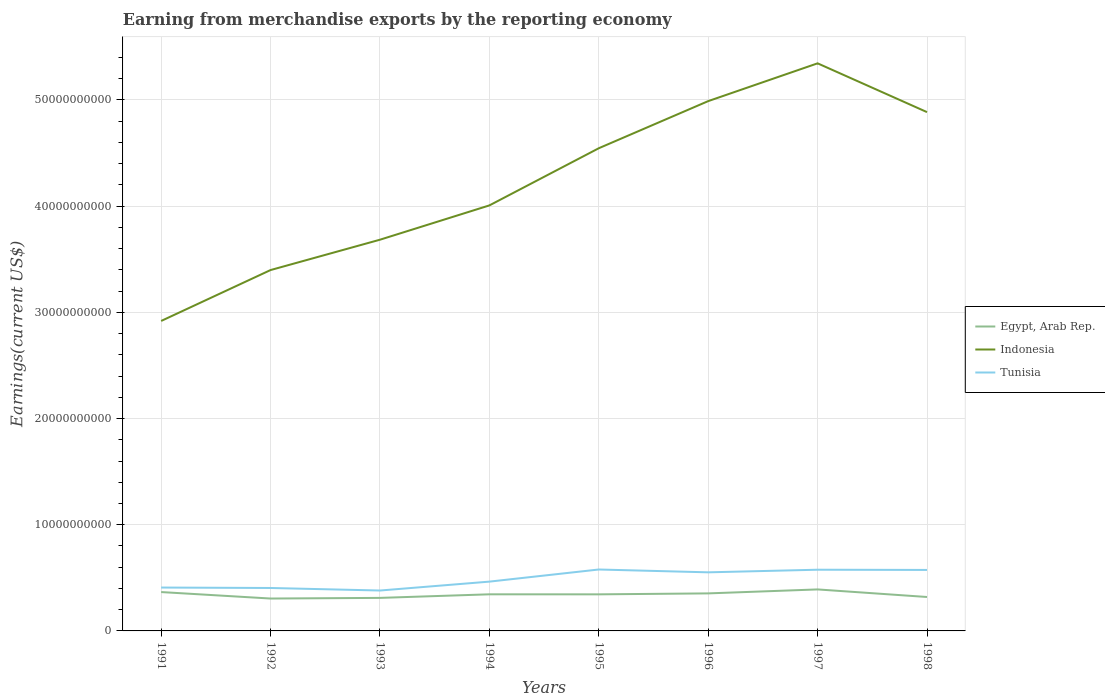How many different coloured lines are there?
Offer a very short reply. 3. Across all years, what is the maximum amount earned from merchandise exports in Egypt, Arab Rep.?
Give a very brief answer. 3.05e+09. In which year was the amount earned from merchandise exports in Egypt, Arab Rep. maximum?
Your answer should be very brief. 1992. What is the total amount earned from merchandise exports in Tunisia in the graph?
Ensure brevity in your answer.  -1.74e+09. What is the difference between the highest and the second highest amount earned from merchandise exports in Egypt, Arab Rep.?
Offer a terse response. 8.58e+08. What is the difference between the highest and the lowest amount earned from merchandise exports in Egypt, Arab Rep.?
Give a very brief answer. 5. Are the values on the major ticks of Y-axis written in scientific E-notation?
Offer a terse response. No. Does the graph contain grids?
Provide a short and direct response. Yes. How are the legend labels stacked?
Offer a terse response. Vertical. What is the title of the graph?
Your answer should be very brief. Earning from merchandise exports by the reporting economy. What is the label or title of the Y-axis?
Offer a terse response. Earnings(current US$). What is the Earnings(current US$) of Egypt, Arab Rep. in 1991?
Make the answer very short. 3.66e+09. What is the Earnings(current US$) of Indonesia in 1991?
Offer a very short reply. 2.92e+1. What is the Earnings(current US$) in Tunisia in 1991?
Offer a very short reply. 4.09e+09. What is the Earnings(current US$) of Egypt, Arab Rep. in 1992?
Provide a short and direct response. 3.05e+09. What is the Earnings(current US$) of Indonesia in 1992?
Provide a succinct answer. 3.40e+1. What is the Earnings(current US$) in Tunisia in 1992?
Ensure brevity in your answer.  4.04e+09. What is the Earnings(current US$) in Egypt, Arab Rep. in 1993?
Make the answer very short. 3.11e+09. What is the Earnings(current US$) of Indonesia in 1993?
Offer a very short reply. 3.68e+1. What is the Earnings(current US$) in Tunisia in 1993?
Offer a very short reply. 3.80e+09. What is the Earnings(current US$) in Egypt, Arab Rep. in 1994?
Your response must be concise. 3.45e+09. What is the Earnings(current US$) in Indonesia in 1994?
Make the answer very short. 4.01e+1. What is the Earnings(current US$) of Tunisia in 1994?
Give a very brief answer. 4.64e+09. What is the Earnings(current US$) of Egypt, Arab Rep. in 1995?
Your answer should be compact. 3.44e+09. What is the Earnings(current US$) in Indonesia in 1995?
Offer a terse response. 4.55e+1. What is the Earnings(current US$) in Tunisia in 1995?
Offer a very short reply. 5.78e+09. What is the Earnings(current US$) of Egypt, Arab Rep. in 1996?
Make the answer very short. 3.53e+09. What is the Earnings(current US$) in Indonesia in 1996?
Provide a succinct answer. 4.99e+1. What is the Earnings(current US$) of Tunisia in 1996?
Provide a succinct answer. 5.52e+09. What is the Earnings(current US$) of Egypt, Arab Rep. in 1997?
Make the answer very short. 3.91e+09. What is the Earnings(current US$) of Indonesia in 1997?
Your answer should be compact. 5.34e+1. What is the Earnings(current US$) of Tunisia in 1997?
Provide a succinct answer. 5.76e+09. What is the Earnings(current US$) in Egypt, Arab Rep. in 1998?
Keep it short and to the point. 3.20e+09. What is the Earnings(current US$) of Indonesia in 1998?
Offer a very short reply. 4.89e+1. What is the Earnings(current US$) of Tunisia in 1998?
Keep it short and to the point. 5.74e+09. Across all years, what is the maximum Earnings(current US$) in Egypt, Arab Rep.?
Your answer should be compact. 3.91e+09. Across all years, what is the maximum Earnings(current US$) of Indonesia?
Your answer should be very brief. 5.34e+1. Across all years, what is the maximum Earnings(current US$) in Tunisia?
Make the answer very short. 5.78e+09. Across all years, what is the minimum Earnings(current US$) in Egypt, Arab Rep.?
Give a very brief answer. 3.05e+09. Across all years, what is the minimum Earnings(current US$) of Indonesia?
Keep it short and to the point. 2.92e+1. Across all years, what is the minimum Earnings(current US$) in Tunisia?
Your answer should be compact. 3.80e+09. What is the total Earnings(current US$) of Egypt, Arab Rep. in the graph?
Provide a succinct answer. 2.73e+1. What is the total Earnings(current US$) in Indonesia in the graph?
Give a very brief answer. 3.38e+11. What is the total Earnings(current US$) in Tunisia in the graph?
Make the answer very short. 3.94e+1. What is the difference between the Earnings(current US$) of Egypt, Arab Rep. in 1991 and that in 1992?
Give a very brief answer. 6.09e+08. What is the difference between the Earnings(current US$) in Indonesia in 1991 and that in 1992?
Give a very brief answer. -4.79e+09. What is the difference between the Earnings(current US$) of Tunisia in 1991 and that in 1992?
Offer a very short reply. 4.13e+07. What is the difference between the Earnings(current US$) of Egypt, Arab Rep. in 1991 and that in 1993?
Your answer should be very brief. 5.49e+08. What is the difference between the Earnings(current US$) in Indonesia in 1991 and that in 1993?
Your response must be concise. -7.65e+09. What is the difference between the Earnings(current US$) in Tunisia in 1991 and that in 1993?
Provide a short and direct response. 2.81e+08. What is the difference between the Earnings(current US$) of Egypt, Arab Rep. in 1991 and that in 1994?
Your answer should be very brief. 2.12e+08. What is the difference between the Earnings(current US$) in Indonesia in 1991 and that in 1994?
Provide a succinct answer. -1.09e+1. What is the difference between the Earnings(current US$) of Tunisia in 1991 and that in 1994?
Your answer should be very brief. -5.57e+08. What is the difference between the Earnings(current US$) in Egypt, Arab Rep. in 1991 and that in 1995?
Provide a short and direct response. 2.15e+08. What is the difference between the Earnings(current US$) in Indonesia in 1991 and that in 1995?
Your response must be concise. -1.63e+1. What is the difference between the Earnings(current US$) of Tunisia in 1991 and that in 1995?
Give a very brief answer. -1.70e+09. What is the difference between the Earnings(current US$) of Egypt, Arab Rep. in 1991 and that in 1996?
Make the answer very short. 1.25e+08. What is the difference between the Earnings(current US$) in Indonesia in 1991 and that in 1996?
Provide a short and direct response. -2.07e+1. What is the difference between the Earnings(current US$) of Tunisia in 1991 and that in 1996?
Ensure brevity in your answer.  -1.43e+09. What is the difference between the Earnings(current US$) in Egypt, Arab Rep. in 1991 and that in 1997?
Offer a terse response. -2.49e+08. What is the difference between the Earnings(current US$) in Indonesia in 1991 and that in 1997?
Your answer should be compact. -2.43e+1. What is the difference between the Earnings(current US$) in Tunisia in 1991 and that in 1997?
Offer a terse response. -1.68e+09. What is the difference between the Earnings(current US$) in Egypt, Arab Rep. in 1991 and that in 1998?
Ensure brevity in your answer.  4.64e+08. What is the difference between the Earnings(current US$) of Indonesia in 1991 and that in 1998?
Provide a succinct answer. -1.97e+1. What is the difference between the Earnings(current US$) in Tunisia in 1991 and that in 1998?
Your answer should be very brief. -1.66e+09. What is the difference between the Earnings(current US$) of Egypt, Arab Rep. in 1992 and that in 1993?
Your answer should be very brief. -6.00e+07. What is the difference between the Earnings(current US$) in Indonesia in 1992 and that in 1993?
Your answer should be very brief. -2.86e+09. What is the difference between the Earnings(current US$) of Tunisia in 1992 and that in 1993?
Ensure brevity in your answer.  2.40e+08. What is the difference between the Earnings(current US$) of Egypt, Arab Rep. in 1992 and that in 1994?
Your answer should be compact. -3.98e+08. What is the difference between the Earnings(current US$) of Indonesia in 1992 and that in 1994?
Your answer should be very brief. -6.09e+09. What is the difference between the Earnings(current US$) of Tunisia in 1992 and that in 1994?
Give a very brief answer. -5.98e+08. What is the difference between the Earnings(current US$) in Egypt, Arab Rep. in 1992 and that in 1995?
Your answer should be compact. -3.94e+08. What is the difference between the Earnings(current US$) in Indonesia in 1992 and that in 1995?
Provide a succinct answer. -1.15e+1. What is the difference between the Earnings(current US$) of Tunisia in 1992 and that in 1995?
Offer a terse response. -1.74e+09. What is the difference between the Earnings(current US$) of Egypt, Arab Rep. in 1992 and that in 1996?
Ensure brevity in your answer.  -4.85e+08. What is the difference between the Earnings(current US$) of Indonesia in 1992 and that in 1996?
Ensure brevity in your answer.  -1.59e+1. What is the difference between the Earnings(current US$) in Tunisia in 1992 and that in 1996?
Provide a succinct answer. -1.47e+09. What is the difference between the Earnings(current US$) in Egypt, Arab Rep. in 1992 and that in 1997?
Offer a very short reply. -8.58e+08. What is the difference between the Earnings(current US$) of Indonesia in 1992 and that in 1997?
Offer a very short reply. -1.95e+1. What is the difference between the Earnings(current US$) in Tunisia in 1992 and that in 1997?
Your response must be concise. -1.72e+09. What is the difference between the Earnings(current US$) of Egypt, Arab Rep. in 1992 and that in 1998?
Provide a short and direct response. -1.45e+08. What is the difference between the Earnings(current US$) of Indonesia in 1992 and that in 1998?
Keep it short and to the point. -1.49e+1. What is the difference between the Earnings(current US$) of Tunisia in 1992 and that in 1998?
Offer a terse response. -1.70e+09. What is the difference between the Earnings(current US$) of Egypt, Arab Rep. in 1993 and that in 1994?
Provide a succinct answer. -3.38e+08. What is the difference between the Earnings(current US$) of Indonesia in 1993 and that in 1994?
Keep it short and to the point. -3.23e+09. What is the difference between the Earnings(current US$) of Tunisia in 1993 and that in 1994?
Provide a succinct answer. -8.38e+08. What is the difference between the Earnings(current US$) in Egypt, Arab Rep. in 1993 and that in 1995?
Offer a very short reply. -3.34e+08. What is the difference between the Earnings(current US$) of Indonesia in 1993 and that in 1995?
Provide a short and direct response. -8.61e+09. What is the difference between the Earnings(current US$) of Tunisia in 1993 and that in 1995?
Provide a short and direct response. -1.98e+09. What is the difference between the Earnings(current US$) of Egypt, Arab Rep. in 1993 and that in 1996?
Your answer should be very brief. -4.25e+08. What is the difference between the Earnings(current US$) of Indonesia in 1993 and that in 1996?
Make the answer very short. -1.31e+1. What is the difference between the Earnings(current US$) of Tunisia in 1993 and that in 1996?
Offer a very short reply. -1.71e+09. What is the difference between the Earnings(current US$) in Egypt, Arab Rep. in 1993 and that in 1997?
Make the answer very short. -7.98e+08. What is the difference between the Earnings(current US$) of Indonesia in 1993 and that in 1997?
Provide a succinct answer. -1.66e+1. What is the difference between the Earnings(current US$) in Tunisia in 1993 and that in 1997?
Provide a short and direct response. -1.96e+09. What is the difference between the Earnings(current US$) of Egypt, Arab Rep. in 1993 and that in 1998?
Keep it short and to the point. -8.53e+07. What is the difference between the Earnings(current US$) in Indonesia in 1993 and that in 1998?
Make the answer very short. -1.20e+1. What is the difference between the Earnings(current US$) of Tunisia in 1993 and that in 1998?
Give a very brief answer. -1.94e+09. What is the difference between the Earnings(current US$) of Egypt, Arab Rep. in 1994 and that in 1995?
Your answer should be compact. 3.36e+06. What is the difference between the Earnings(current US$) of Indonesia in 1994 and that in 1995?
Offer a very short reply. -5.38e+09. What is the difference between the Earnings(current US$) in Tunisia in 1994 and that in 1995?
Offer a terse response. -1.14e+09. What is the difference between the Earnings(current US$) of Egypt, Arab Rep. in 1994 and that in 1996?
Offer a terse response. -8.70e+07. What is the difference between the Earnings(current US$) in Indonesia in 1994 and that in 1996?
Keep it short and to the point. -9.82e+09. What is the difference between the Earnings(current US$) in Tunisia in 1994 and that in 1996?
Ensure brevity in your answer.  -8.76e+08. What is the difference between the Earnings(current US$) in Egypt, Arab Rep. in 1994 and that in 1997?
Your response must be concise. -4.60e+08. What is the difference between the Earnings(current US$) in Indonesia in 1994 and that in 1997?
Your answer should be compact. -1.34e+1. What is the difference between the Earnings(current US$) of Tunisia in 1994 and that in 1997?
Give a very brief answer. -1.12e+09. What is the difference between the Earnings(current US$) in Egypt, Arab Rep. in 1994 and that in 1998?
Offer a terse response. 2.52e+08. What is the difference between the Earnings(current US$) of Indonesia in 1994 and that in 1998?
Offer a very short reply. -8.79e+09. What is the difference between the Earnings(current US$) in Tunisia in 1994 and that in 1998?
Give a very brief answer. -1.10e+09. What is the difference between the Earnings(current US$) of Egypt, Arab Rep. in 1995 and that in 1996?
Make the answer very short. -9.03e+07. What is the difference between the Earnings(current US$) in Indonesia in 1995 and that in 1996?
Your answer should be very brief. -4.44e+09. What is the difference between the Earnings(current US$) of Tunisia in 1995 and that in 1996?
Keep it short and to the point. 2.66e+08. What is the difference between the Earnings(current US$) in Egypt, Arab Rep. in 1995 and that in 1997?
Provide a succinct answer. -4.64e+08. What is the difference between the Earnings(current US$) of Indonesia in 1995 and that in 1997?
Your answer should be very brief. -8.00e+09. What is the difference between the Earnings(current US$) in Tunisia in 1995 and that in 1997?
Make the answer very short. 2.11e+07. What is the difference between the Earnings(current US$) in Egypt, Arab Rep. in 1995 and that in 1998?
Keep it short and to the point. 2.49e+08. What is the difference between the Earnings(current US$) of Indonesia in 1995 and that in 1998?
Offer a terse response. -3.40e+09. What is the difference between the Earnings(current US$) in Tunisia in 1995 and that in 1998?
Make the answer very short. 4.17e+07. What is the difference between the Earnings(current US$) in Egypt, Arab Rep. in 1996 and that in 1997?
Keep it short and to the point. -3.73e+08. What is the difference between the Earnings(current US$) of Indonesia in 1996 and that in 1997?
Offer a very short reply. -3.56e+09. What is the difference between the Earnings(current US$) of Tunisia in 1996 and that in 1997?
Offer a terse response. -2.45e+08. What is the difference between the Earnings(current US$) in Egypt, Arab Rep. in 1996 and that in 1998?
Make the answer very short. 3.39e+08. What is the difference between the Earnings(current US$) in Indonesia in 1996 and that in 1998?
Your answer should be compact. 1.03e+09. What is the difference between the Earnings(current US$) of Tunisia in 1996 and that in 1998?
Your answer should be very brief. -2.24e+08. What is the difference between the Earnings(current US$) of Egypt, Arab Rep. in 1997 and that in 1998?
Keep it short and to the point. 7.13e+08. What is the difference between the Earnings(current US$) of Indonesia in 1997 and that in 1998?
Provide a short and direct response. 4.59e+09. What is the difference between the Earnings(current US$) of Tunisia in 1997 and that in 1998?
Make the answer very short. 2.06e+07. What is the difference between the Earnings(current US$) of Egypt, Arab Rep. in 1991 and the Earnings(current US$) of Indonesia in 1992?
Keep it short and to the point. -3.03e+1. What is the difference between the Earnings(current US$) of Egypt, Arab Rep. in 1991 and the Earnings(current US$) of Tunisia in 1992?
Provide a short and direct response. -3.85e+08. What is the difference between the Earnings(current US$) of Indonesia in 1991 and the Earnings(current US$) of Tunisia in 1992?
Your answer should be compact. 2.51e+1. What is the difference between the Earnings(current US$) in Egypt, Arab Rep. in 1991 and the Earnings(current US$) in Indonesia in 1993?
Your response must be concise. -3.32e+1. What is the difference between the Earnings(current US$) in Egypt, Arab Rep. in 1991 and the Earnings(current US$) in Tunisia in 1993?
Provide a short and direct response. -1.45e+08. What is the difference between the Earnings(current US$) in Indonesia in 1991 and the Earnings(current US$) in Tunisia in 1993?
Make the answer very short. 2.54e+1. What is the difference between the Earnings(current US$) in Egypt, Arab Rep. in 1991 and the Earnings(current US$) in Indonesia in 1994?
Provide a succinct answer. -3.64e+1. What is the difference between the Earnings(current US$) of Egypt, Arab Rep. in 1991 and the Earnings(current US$) of Tunisia in 1994?
Provide a succinct answer. -9.83e+08. What is the difference between the Earnings(current US$) in Indonesia in 1991 and the Earnings(current US$) in Tunisia in 1994?
Keep it short and to the point. 2.45e+1. What is the difference between the Earnings(current US$) in Egypt, Arab Rep. in 1991 and the Earnings(current US$) in Indonesia in 1995?
Your answer should be very brief. -4.18e+1. What is the difference between the Earnings(current US$) of Egypt, Arab Rep. in 1991 and the Earnings(current US$) of Tunisia in 1995?
Provide a short and direct response. -2.12e+09. What is the difference between the Earnings(current US$) of Indonesia in 1991 and the Earnings(current US$) of Tunisia in 1995?
Offer a very short reply. 2.34e+1. What is the difference between the Earnings(current US$) in Egypt, Arab Rep. in 1991 and the Earnings(current US$) in Indonesia in 1996?
Keep it short and to the point. -4.62e+1. What is the difference between the Earnings(current US$) in Egypt, Arab Rep. in 1991 and the Earnings(current US$) in Tunisia in 1996?
Give a very brief answer. -1.86e+09. What is the difference between the Earnings(current US$) of Indonesia in 1991 and the Earnings(current US$) of Tunisia in 1996?
Make the answer very short. 2.37e+1. What is the difference between the Earnings(current US$) of Egypt, Arab Rep. in 1991 and the Earnings(current US$) of Indonesia in 1997?
Keep it short and to the point. -4.98e+1. What is the difference between the Earnings(current US$) in Egypt, Arab Rep. in 1991 and the Earnings(current US$) in Tunisia in 1997?
Make the answer very short. -2.10e+09. What is the difference between the Earnings(current US$) of Indonesia in 1991 and the Earnings(current US$) of Tunisia in 1997?
Make the answer very short. 2.34e+1. What is the difference between the Earnings(current US$) in Egypt, Arab Rep. in 1991 and the Earnings(current US$) in Indonesia in 1998?
Ensure brevity in your answer.  -4.52e+1. What is the difference between the Earnings(current US$) in Egypt, Arab Rep. in 1991 and the Earnings(current US$) in Tunisia in 1998?
Your response must be concise. -2.08e+09. What is the difference between the Earnings(current US$) of Indonesia in 1991 and the Earnings(current US$) of Tunisia in 1998?
Offer a terse response. 2.34e+1. What is the difference between the Earnings(current US$) of Egypt, Arab Rep. in 1992 and the Earnings(current US$) of Indonesia in 1993?
Give a very brief answer. -3.38e+1. What is the difference between the Earnings(current US$) in Egypt, Arab Rep. in 1992 and the Earnings(current US$) in Tunisia in 1993?
Provide a succinct answer. -7.54e+08. What is the difference between the Earnings(current US$) of Indonesia in 1992 and the Earnings(current US$) of Tunisia in 1993?
Give a very brief answer. 3.02e+1. What is the difference between the Earnings(current US$) of Egypt, Arab Rep. in 1992 and the Earnings(current US$) of Indonesia in 1994?
Your answer should be very brief. -3.70e+1. What is the difference between the Earnings(current US$) in Egypt, Arab Rep. in 1992 and the Earnings(current US$) in Tunisia in 1994?
Ensure brevity in your answer.  -1.59e+09. What is the difference between the Earnings(current US$) of Indonesia in 1992 and the Earnings(current US$) of Tunisia in 1994?
Your answer should be very brief. 2.93e+1. What is the difference between the Earnings(current US$) in Egypt, Arab Rep. in 1992 and the Earnings(current US$) in Indonesia in 1995?
Your answer should be compact. -4.24e+1. What is the difference between the Earnings(current US$) in Egypt, Arab Rep. in 1992 and the Earnings(current US$) in Tunisia in 1995?
Give a very brief answer. -2.73e+09. What is the difference between the Earnings(current US$) of Indonesia in 1992 and the Earnings(current US$) of Tunisia in 1995?
Your response must be concise. 2.82e+1. What is the difference between the Earnings(current US$) in Egypt, Arab Rep. in 1992 and the Earnings(current US$) in Indonesia in 1996?
Keep it short and to the point. -4.68e+1. What is the difference between the Earnings(current US$) in Egypt, Arab Rep. in 1992 and the Earnings(current US$) in Tunisia in 1996?
Offer a very short reply. -2.47e+09. What is the difference between the Earnings(current US$) of Indonesia in 1992 and the Earnings(current US$) of Tunisia in 1996?
Make the answer very short. 2.85e+1. What is the difference between the Earnings(current US$) of Egypt, Arab Rep. in 1992 and the Earnings(current US$) of Indonesia in 1997?
Make the answer very short. -5.04e+1. What is the difference between the Earnings(current US$) in Egypt, Arab Rep. in 1992 and the Earnings(current US$) in Tunisia in 1997?
Your response must be concise. -2.71e+09. What is the difference between the Earnings(current US$) in Indonesia in 1992 and the Earnings(current US$) in Tunisia in 1997?
Offer a very short reply. 2.82e+1. What is the difference between the Earnings(current US$) of Egypt, Arab Rep. in 1992 and the Earnings(current US$) of Indonesia in 1998?
Give a very brief answer. -4.58e+1. What is the difference between the Earnings(current US$) of Egypt, Arab Rep. in 1992 and the Earnings(current US$) of Tunisia in 1998?
Your answer should be compact. -2.69e+09. What is the difference between the Earnings(current US$) in Indonesia in 1992 and the Earnings(current US$) in Tunisia in 1998?
Your answer should be very brief. 2.82e+1. What is the difference between the Earnings(current US$) in Egypt, Arab Rep. in 1993 and the Earnings(current US$) in Indonesia in 1994?
Provide a short and direct response. -3.70e+1. What is the difference between the Earnings(current US$) in Egypt, Arab Rep. in 1993 and the Earnings(current US$) in Tunisia in 1994?
Offer a very short reply. -1.53e+09. What is the difference between the Earnings(current US$) of Indonesia in 1993 and the Earnings(current US$) of Tunisia in 1994?
Your response must be concise. 3.22e+1. What is the difference between the Earnings(current US$) in Egypt, Arab Rep. in 1993 and the Earnings(current US$) in Indonesia in 1995?
Keep it short and to the point. -4.23e+1. What is the difference between the Earnings(current US$) of Egypt, Arab Rep. in 1993 and the Earnings(current US$) of Tunisia in 1995?
Your response must be concise. -2.67e+09. What is the difference between the Earnings(current US$) in Indonesia in 1993 and the Earnings(current US$) in Tunisia in 1995?
Keep it short and to the point. 3.11e+1. What is the difference between the Earnings(current US$) in Egypt, Arab Rep. in 1993 and the Earnings(current US$) in Indonesia in 1996?
Your response must be concise. -4.68e+1. What is the difference between the Earnings(current US$) in Egypt, Arab Rep. in 1993 and the Earnings(current US$) in Tunisia in 1996?
Make the answer very short. -2.41e+09. What is the difference between the Earnings(current US$) of Indonesia in 1993 and the Earnings(current US$) of Tunisia in 1996?
Provide a short and direct response. 3.13e+1. What is the difference between the Earnings(current US$) in Egypt, Arab Rep. in 1993 and the Earnings(current US$) in Indonesia in 1997?
Make the answer very short. -5.03e+1. What is the difference between the Earnings(current US$) in Egypt, Arab Rep. in 1993 and the Earnings(current US$) in Tunisia in 1997?
Your answer should be compact. -2.65e+09. What is the difference between the Earnings(current US$) of Indonesia in 1993 and the Earnings(current US$) of Tunisia in 1997?
Provide a succinct answer. 3.11e+1. What is the difference between the Earnings(current US$) of Egypt, Arab Rep. in 1993 and the Earnings(current US$) of Indonesia in 1998?
Keep it short and to the point. -4.57e+1. What is the difference between the Earnings(current US$) of Egypt, Arab Rep. in 1993 and the Earnings(current US$) of Tunisia in 1998?
Your response must be concise. -2.63e+09. What is the difference between the Earnings(current US$) in Indonesia in 1993 and the Earnings(current US$) in Tunisia in 1998?
Give a very brief answer. 3.11e+1. What is the difference between the Earnings(current US$) of Egypt, Arab Rep. in 1994 and the Earnings(current US$) of Indonesia in 1995?
Ensure brevity in your answer.  -4.20e+1. What is the difference between the Earnings(current US$) of Egypt, Arab Rep. in 1994 and the Earnings(current US$) of Tunisia in 1995?
Make the answer very short. -2.34e+09. What is the difference between the Earnings(current US$) of Indonesia in 1994 and the Earnings(current US$) of Tunisia in 1995?
Your response must be concise. 3.43e+1. What is the difference between the Earnings(current US$) in Egypt, Arab Rep. in 1994 and the Earnings(current US$) in Indonesia in 1996?
Ensure brevity in your answer.  -4.64e+1. What is the difference between the Earnings(current US$) in Egypt, Arab Rep. in 1994 and the Earnings(current US$) in Tunisia in 1996?
Give a very brief answer. -2.07e+09. What is the difference between the Earnings(current US$) of Indonesia in 1994 and the Earnings(current US$) of Tunisia in 1996?
Offer a terse response. 3.46e+1. What is the difference between the Earnings(current US$) in Egypt, Arab Rep. in 1994 and the Earnings(current US$) in Indonesia in 1997?
Offer a terse response. -5.00e+1. What is the difference between the Earnings(current US$) of Egypt, Arab Rep. in 1994 and the Earnings(current US$) of Tunisia in 1997?
Keep it short and to the point. -2.32e+09. What is the difference between the Earnings(current US$) of Indonesia in 1994 and the Earnings(current US$) of Tunisia in 1997?
Offer a very short reply. 3.43e+1. What is the difference between the Earnings(current US$) in Egypt, Arab Rep. in 1994 and the Earnings(current US$) in Indonesia in 1998?
Your answer should be compact. -4.54e+1. What is the difference between the Earnings(current US$) in Egypt, Arab Rep. in 1994 and the Earnings(current US$) in Tunisia in 1998?
Offer a very short reply. -2.29e+09. What is the difference between the Earnings(current US$) in Indonesia in 1994 and the Earnings(current US$) in Tunisia in 1998?
Your answer should be very brief. 3.43e+1. What is the difference between the Earnings(current US$) of Egypt, Arab Rep. in 1995 and the Earnings(current US$) of Indonesia in 1996?
Provide a short and direct response. -4.64e+1. What is the difference between the Earnings(current US$) in Egypt, Arab Rep. in 1995 and the Earnings(current US$) in Tunisia in 1996?
Your response must be concise. -2.07e+09. What is the difference between the Earnings(current US$) of Indonesia in 1995 and the Earnings(current US$) of Tunisia in 1996?
Ensure brevity in your answer.  3.99e+1. What is the difference between the Earnings(current US$) in Egypt, Arab Rep. in 1995 and the Earnings(current US$) in Indonesia in 1997?
Your answer should be very brief. -5.00e+1. What is the difference between the Earnings(current US$) in Egypt, Arab Rep. in 1995 and the Earnings(current US$) in Tunisia in 1997?
Provide a succinct answer. -2.32e+09. What is the difference between the Earnings(current US$) of Indonesia in 1995 and the Earnings(current US$) of Tunisia in 1997?
Your answer should be very brief. 3.97e+1. What is the difference between the Earnings(current US$) of Egypt, Arab Rep. in 1995 and the Earnings(current US$) of Indonesia in 1998?
Make the answer very short. -4.54e+1. What is the difference between the Earnings(current US$) in Egypt, Arab Rep. in 1995 and the Earnings(current US$) in Tunisia in 1998?
Your answer should be very brief. -2.30e+09. What is the difference between the Earnings(current US$) in Indonesia in 1995 and the Earnings(current US$) in Tunisia in 1998?
Provide a short and direct response. 3.97e+1. What is the difference between the Earnings(current US$) of Egypt, Arab Rep. in 1996 and the Earnings(current US$) of Indonesia in 1997?
Your response must be concise. -4.99e+1. What is the difference between the Earnings(current US$) of Egypt, Arab Rep. in 1996 and the Earnings(current US$) of Tunisia in 1997?
Offer a very short reply. -2.23e+09. What is the difference between the Earnings(current US$) in Indonesia in 1996 and the Earnings(current US$) in Tunisia in 1997?
Offer a terse response. 4.41e+1. What is the difference between the Earnings(current US$) in Egypt, Arab Rep. in 1996 and the Earnings(current US$) in Indonesia in 1998?
Keep it short and to the point. -4.53e+1. What is the difference between the Earnings(current US$) in Egypt, Arab Rep. in 1996 and the Earnings(current US$) in Tunisia in 1998?
Give a very brief answer. -2.21e+09. What is the difference between the Earnings(current US$) in Indonesia in 1996 and the Earnings(current US$) in Tunisia in 1998?
Provide a short and direct response. 4.41e+1. What is the difference between the Earnings(current US$) in Egypt, Arab Rep. in 1997 and the Earnings(current US$) in Indonesia in 1998?
Offer a very short reply. -4.49e+1. What is the difference between the Earnings(current US$) in Egypt, Arab Rep. in 1997 and the Earnings(current US$) in Tunisia in 1998?
Your answer should be compact. -1.83e+09. What is the difference between the Earnings(current US$) in Indonesia in 1997 and the Earnings(current US$) in Tunisia in 1998?
Your response must be concise. 4.77e+1. What is the average Earnings(current US$) in Egypt, Arab Rep. per year?
Offer a terse response. 3.42e+09. What is the average Earnings(current US$) in Indonesia per year?
Your response must be concise. 4.22e+1. What is the average Earnings(current US$) of Tunisia per year?
Ensure brevity in your answer.  4.92e+09. In the year 1991, what is the difference between the Earnings(current US$) of Egypt, Arab Rep. and Earnings(current US$) of Indonesia?
Keep it short and to the point. -2.55e+1. In the year 1991, what is the difference between the Earnings(current US$) in Egypt, Arab Rep. and Earnings(current US$) in Tunisia?
Your answer should be very brief. -4.26e+08. In the year 1991, what is the difference between the Earnings(current US$) of Indonesia and Earnings(current US$) of Tunisia?
Provide a succinct answer. 2.51e+1. In the year 1992, what is the difference between the Earnings(current US$) in Egypt, Arab Rep. and Earnings(current US$) in Indonesia?
Offer a very short reply. -3.09e+1. In the year 1992, what is the difference between the Earnings(current US$) in Egypt, Arab Rep. and Earnings(current US$) in Tunisia?
Provide a short and direct response. -9.94e+08. In the year 1992, what is the difference between the Earnings(current US$) in Indonesia and Earnings(current US$) in Tunisia?
Your answer should be compact. 2.99e+1. In the year 1993, what is the difference between the Earnings(current US$) of Egypt, Arab Rep. and Earnings(current US$) of Indonesia?
Make the answer very short. -3.37e+1. In the year 1993, what is the difference between the Earnings(current US$) in Egypt, Arab Rep. and Earnings(current US$) in Tunisia?
Provide a succinct answer. -6.94e+08. In the year 1993, what is the difference between the Earnings(current US$) of Indonesia and Earnings(current US$) of Tunisia?
Give a very brief answer. 3.30e+1. In the year 1994, what is the difference between the Earnings(current US$) in Egypt, Arab Rep. and Earnings(current US$) in Indonesia?
Offer a terse response. -3.66e+1. In the year 1994, what is the difference between the Earnings(current US$) in Egypt, Arab Rep. and Earnings(current US$) in Tunisia?
Make the answer very short. -1.19e+09. In the year 1994, what is the difference between the Earnings(current US$) of Indonesia and Earnings(current US$) of Tunisia?
Provide a short and direct response. 3.54e+1. In the year 1995, what is the difference between the Earnings(current US$) of Egypt, Arab Rep. and Earnings(current US$) of Indonesia?
Your response must be concise. -4.20e+1. In the year 1995, what is the difference between the Earnings(current US$) of Egypt, Arab Rep. and Earnings(current US$) of Tunisia?
Your response must be concise. -2.34e+09. In the year 1995, what is the difference between the Earnings(current US$) of Indonesia and Earnings(current US$) of Tunisia?
Ensure brevity in your answer.  3.97e+1. In the year 1996, what is the difference between the Earnings(current US$) in Egypt, Arab Rep. and Earnings(current US$) in Indonesia?
Keep it short and to the point. -4.64e+1. In the year 1996, what is the difference between the Earnings(current US$) of Egypt, Arab Rep. and Earnings(current US$) of Tunisia?
Your response must be concise. -1.98e+09. In the year 1996, what is the difference between the Earnings(current US$) in Indonesia and Earnings(current US$) in Tunisia?
Your response must be concise. 4.44e+1. In the year 1997, what is the difference between the Earnings(current US$) of Egypt, Arab Rep. and Earnings(current US$) of Indonesia?
Make the answer very short. -4.95e+1. In the year 1997, what is the difference between the Earnings(current US$) in Egypt, Arab Rep. and Earnings(current US$) in Tunisia?
Keep it short and to the point. -1.85e+09. In the year 1997, what is the difference between the Earnings(current US$) of Indonesia and Earnings(current US$) of Tunisia?
Provide a succinct answer. 4.77e+1. In the year 1998, what is the difference between the Earnings(current US$) of Egypt, Arab Rep. and Earnings(current US$) of Indonesia?
Offer a terse response. -4.57e+1. In the year 1998, what is the difference between the Earnings(current US$) in Egypt, Arab Rep. and Earnings(current US$) in Tunisia?
Make the answer very short. -2.55e+09. In the year 1998, what is the difference between the Earnings(current US$) in Indonesia and Earnings(current US$) in Tunisia?
Make the answer very short. 4.31e+1. What is the ratio of the Earnings(current US$) in Egypt, Arab Rep. in 1991 to that in 1992?
Ensure brevity in your answer.  1.2. What is the ratio of the Earnings(current US$) in Indonesia in 1991 to that in 1992?
Give a very brief answer. 0.86. What is the ratio of the Earnings(current US$) of Tunisia in 1991 to that in 1992?
Give a very brief answer. 1.01. What is the ratio of the Earnings(current US$) in Egypt, Arab Rep. in 1991 to that in 1993?
Provide a succinct answer. 1.18. What is the ratio of the Earnings(current US$) in Indonesia in 1991 to that in 1993?
Your answer should be compact. 0.79. What is the ratio of the Earnings(current US$) of Tunisia in 1991 to that in 1993?
Keep it short and to the point. 1.07. What is the ratio of the Earnings(current US$) of Egypt, Arab Rep. in 1991 to that in 1994?
Make the answer very short. 1.06. What is the ratio of the Earnings(current US$) of Indonesia in 1991 to that in 1994?
Your answer should be very brief. 0.73. What is the ratio of the Earnings(current US$) of Tunisia in 1991 to that in 1994?
Provide a short and direct response. 0.88. What is the ratio of the Earnings(current US$) in Indonesia in 1991 to that in 1995?
Keep it short and to the point. 0.64. What is the ratio of the Earnings(current US$) in Tunisia in 1991 to that in 1995?
Offer a terse response. 0.71. What is the ratio of the Earnings(current US$) of Egypt, Arab Rep. in 1991 to that in 1996?
Your answer should be compact. 1.04. What is the ratio of the Earnings(current US$) in Indonesia in 1991 to that in 1996?
Give a very brief answer. 0.59. What is the ratio of the Earnings(current US$) of Tunisia in 1991 to that in 1996?
Make the answer very short. 0.74. What is the ratio of the Earnings(current US$) of Egypt, Arab Rep. in 1991 to that in 1997?
Ensure brevity in your answer.  0.94. What is the ratio of the Earnings(current US$) in Indonesia in 1991 to that in 1997?
Ensure brevity in your answer.  0.55. What is the ratio of the Earnings(current US$) in Tunisia in 1991 to that in 1997?
Ensure brevity in your answer.  0.71. What is the ratio of the Earnings(current US$) in Egypt, Arab Rep. in 1991 to that in 1998?
Offer a terse response. 1.15. What is the ratio of the Earnings(current US$) in Indonesia in 1991 to that in 1998?
Make the answer very short. 0.6. What is the ratio of the Earnings(current US$) of Tunisia in 1991 to that in 1998?
Offer a very short reply. 0.71. What is the ratio of the Earnings(current US$) in Egypt, Arab Rep. in 1992 to that in 1993?
Provide a succinct answer. 0.98. What is the ratio of the Earnings(current US$) of Indonesia in 1992 to that in 1993?
Provide a succinct answer. 0.92. What is the ratio of the Earnings(current US$) of Tunisia in 1992 to that in 1993?
Your answer should be compact. 1.06. What is the ratio of the Earnings(current US$) in Egypt, Arab Rep. in 1992 to that in 1994?
Provide a short and direct response. 0.88. What is the ratio of the Earnings(current US$) of Indonesia in 1992 to that in 1994?
Your answer should be compact. 0.85. What is the ratio of the Earnings(current US$) in Tunisia in 1992 to that in 1994?
Provide a short and direct response. 0.87. What is the ratio of the Earnings(current US$) in Egypt, Arab Rep. in 1992 to that in 1995?
Provide a succinct answer. 0.89. What is the ratio of the Earnings(current US$) in Indonesia in 1992 to that in 1995?
Offer a very short reply. 0.75. What is the ratio of the Earnings(current US$) in Tunisia in 1992 to that in 1995?
Your response must be concise. 0.7. What is the ratio of the Earnings(current US$) of Egypt, Arab Rep. in 1992 to that in 1996?
Make the answer very short. 0.86. What is the ratio of the Earnings(current US$) of Indonesia in 1992 to that in 1996?
Provide a short and direct response. 0.68. What is the ratio of the Earnings(current US$) in Tunisia in 1992 to that in 1996?
Provide a short and direct response. 0.73. What is the ratio of the Earnings(current US$) of Egypt, Arab Rep. in 1992 to that in 1997?
Your response must be concise. 0.78. What is the ratio of the Earnings(current US$) in Indonesia in 1992 to that in 1997?
Ensure brevity in your answer.  0.64. What is the ratio of the Earnings(current US$) of Tunisia in 1992 to that in 1997?
Make the answer very short. 0.7. What is the ratio of the Earnings(current US$) of Egypt, Arab Rep. in 1992 to that in 1998?
Make the answer very short. 0.95. What is the ratio of the Earnings(current US$) in Indonesia in 1992 to that in 1998?
Your response must be concise. 0.7. What is the ratio of the Earnings(current US$) in Tunisia in 1992 to that in 1998?
Make the answer very short. 0.7. What is the ratio of the Earnings(current US$) in Egypt, Arab Rep. in 1993 to that in 1994?
Give a very brief answer. 0.9. What is the ratio of the Earnings(current US$) in Indonesia in 1993 to that in 1994?
Your answer should be compact. 0.92. What is the ratio of the Earnings(current US$) of Tunisia in 1993 to that in 1994?
Your answer should be very brief. 0.82. What is the ratio of the Earnings(current US$) in Egypt, Arab Rep. in 1993 to that in 1995?
Your response must be concise. 0.9. What is the ratio of the Earnings(current US$) of Indonesia in 1993 to that in 1995?
Keep it short and to the point. 0.81. What is the ratio of the Earnings(current US$) in Tunisia in 1993 to that in 1995?
Offer a very short reply. 0.66. What is the ratio of the Earnings(current US$) of Egypt, Arab Rep. in 1993 to that in 1996?
Give a very brief answer. 0.88. What is the ratio of the Earnings(current US$) in Indonesia in 1993 to that in 1996?
Provide a succinct answer. 0.74. What is the ratio of the Earnings(current US$) of Tunisia in 1993 to that in 1996?
Offer a terse response. 0.69. What is the ratio of the Earnings(current US$) in Egypt, Arab Rep. in 1993 to that in 1997?
Your answer should be compact. 0.8. What is the ratio of the Earnings(current US$) in Indonesia in 1993 to that in 1997?
Your answer should be very brief. 0.69. What is the ratio of the Earnings(current US$) of Tunisia in 1993 to that in 1997?
Offer a terse response. 0.66. What is the ratio of the Earnings(current US$) in Egypt, Arab Rep. in 1993 to that in 1998?
Your answer should be very brief. 0.97. What is the ratio of the Earnings(current US$) of Indonesia in 1993 to that in 1998?
Your answer should be very brief. 0.75. What is the ratio of the Earnings(current US$) of Tunisia in 1993 to that in 1998?
Your answer should be compact. 0.66. What is the ratio of the Earnings(current US$) in Indonesia in 1994 to that in 1995?
Offer a terse response. 0.88. What is the ratio of the Earnings(current US$) in Tunisia in 1994 to that in 1995?
Give a very brief answer. 0.8. What is the ratio of the Earnings(current US$) of Egypt, Arab Rep. in 1994 to that in 1996?
Make the answer very short. 0.98. What is the ratio of the Earnings(current US$) in Indonesia in 1994 to that in 1996?
Provide a short and direct response. 0.8. What is the ratio of the Earnings(current US$) of Tunisia in 1994 to that in 1996?
Ensure brevity in your answer.  0.84. What is the ratio of the Earnings(current US$) in Egypt, Arab Rep. in 1994 to that in 1997?
Keep it short and to the point. 0.88. What is the ratio of the Earnings(current US$) in Indonesia in 1994 to that in 1997?
Ensure brevity in your answer.  0.75. What is the ratio of the Earnings(current US$) of Tunisia in 1994 to that in 1997?
Your response must be concise. 0.81. What is the ratio of the Earnings(current US$) of Egypt, Arab Rep. in 1994 to that in 1998?
Give a very brief answer. 1.08. What is the ratio of the Earnings(current US$) of Indonesia in 1994 to that in 1998?
Your response must be concise. 0.82. What is the ratio of the Earnings(current US$) in Tunisia in 1994 to that in 1998?
Ensure brevity in your answer.  0.81. What is the ratio of the Earnings(current US$) of Egypt, Arab Rep. in 1995 to that in 1996?
Your answer should be very brief. 0.97. What is the ratio of the Earnings(current US$) in Indonesia in 1995 to that in 1996?
Keep it short and to the point. 0.91. What is the ratio of the Earnings(current US$) in Tunisia in 1995 to that in 1996?
Keep it short and to the point. 1.05. What is the ratio of the Earnings(current US$) in Egypt, Arab Rep. in 1995 to that in 1997?
Ensure brevity in your answer.  0.88. What is the ratio of the Earnings(current US$) in Indonesia in 1995 to that in 1997?
Your response must be concise. 0.85. What is the ratio of the Earnings(current US$) of Tunisia in 1995 to that in 1997?
Offer a very short reply. 1. What is the ratio of the Earnings(current US$) in Egypt, Arab Rep. in 1995 to that in 1998?
Offer a terse response. 1.08. What is the ratio of the Earnings(current US$) in Indonesia in 1995 to that in 1998?
Your response must be concise. 0.93. What is the ratio of the Earnings(current US$) of Tunisia in 1995 to that in 1998?
Provide a succinct answer. 1.01. What is the ratio of the Earnings(current US$) in Egypt, Arab Rep. in 1996 to that in 1997?
Your response must be concise. 0.9. What is the ratio of the Earnings(current US$) of Indonesia in 1996 to that in 1997?
Provide a succinct answer. 0.93. What is the ratio of the Earnings(current US$) in Tunisia in 1996 to that in 1997?
Your answer should be very brief. 0.96. What is the ratio of the Earnings(current US$) of Egypt, Arab Rep. in 1996 to that in 1998?
Provide a succinct answer. 1.11. What is the ratio of the Earnings(current US$) of Indonesia in 1996 to that in 1998?
Provide a short and direct response. 1.02. What is the ratio of the Earnings(current US$) of Tunisia in 1996 to that in 1998?
Your response must be concise. 0.96. What is the ratio of the Earnings(current US$) in Egypt, Arab Rep. in 1997 to that in 1998?
Your response must be concise. 1.22. What is the ratio of the Earnings(current US$) in Indonesia in 1997 to that in 1998?
Offer a terse response. 1.09. What is the ratio of the Earnings(current US$) in Tunisia in 1997 to that in 1998?
Provide a short and direct response. 1. What is the difference between the highest and the second highest Earnings(current US$) of Egypt, Arab Rep.?
Ensure brevity in your answer.  2.49e+08. What is the difference between the highest and the second highest Earnings(current US$) in Indonesia?
Your answer should be very brief. 3.56e+09. What is the difference between the highest and the second highest Earnings(current US$) of Tunisia?
Your response must be concise. 2.11e+07. What is the difference between the highest and the lowest Earnings(current US$) of Egypt, Arab Rep.?
Your response must be concise. 8.58e+08. What is the difference between the highest and the lowest Earnings(current US$) of Indonesia?
Give a very brief answer. 2.43e+1. What is the difference between the highest and the lowest Earnings(current US$) of Tunisia?
Make the answer very short. 1.98e+09. 